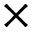Convert formula to latex. <formula><loc_0><loc_0><loc_500><loc_500>\times</formula> 